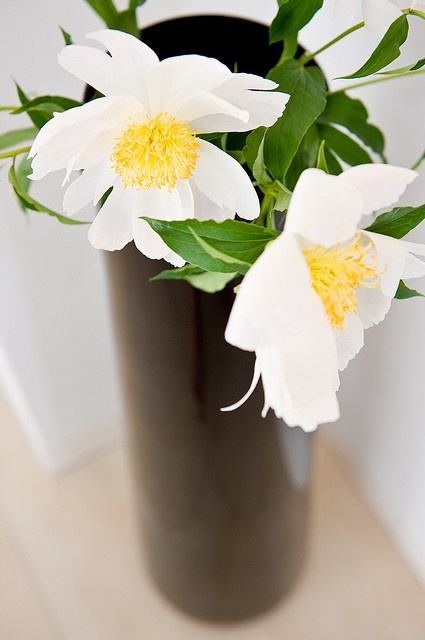Describe the objects in this image and their specific colors. I can see potted plant in lightgray, black, darkgreen, and gray tones, vase in lightgray, black, and gray tones, and vase in lightgray, black, olive, and gray tones in this image. 